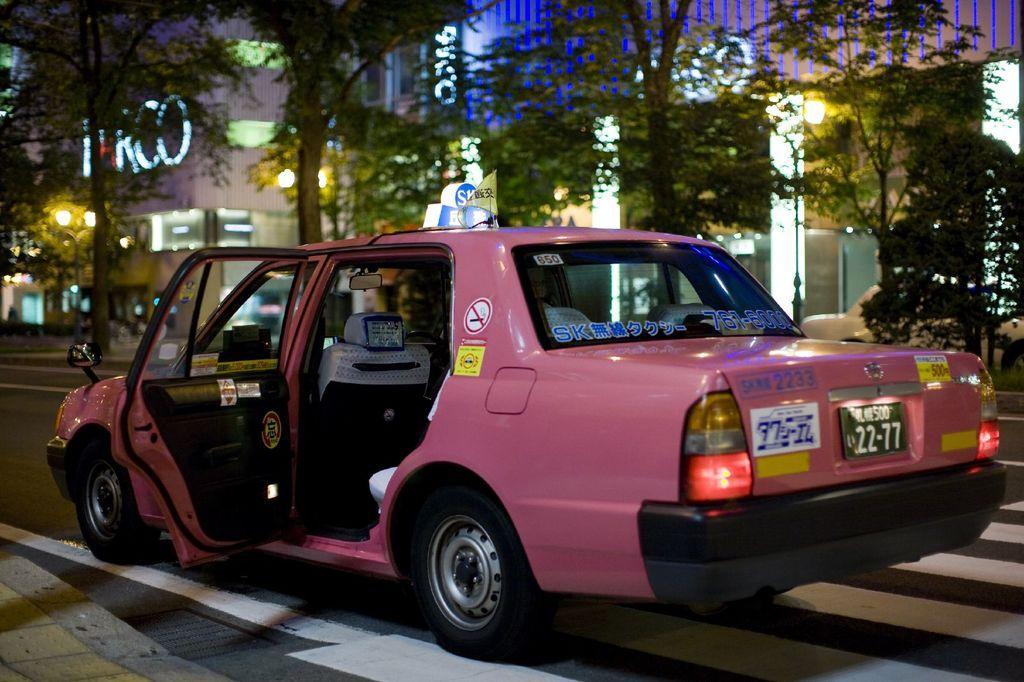How would you summarize this image in a sentence or two? In this picture we can see a car on the road, trees and in the background we can see buildings. 